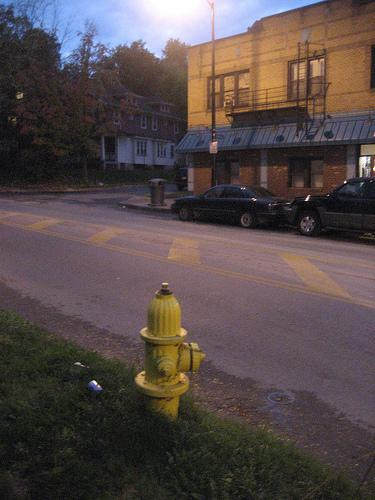Can you identify the type and colors of vehicles in the image and their parking positions? There are two black vehicles, a car and a truck, parked on the street with the car in front of the truck. Mention any unusual marking present on the road surface, and state its color. Blue paint markings are present on the road surface, which may indicate construction or maintenance work. In one sentence, describe the primary subject of the image and its color. The primary subject of the image is a yellow fire hydrant, placed on the street to assist firefighters. What object can be found in the grass, and what is its purpose? A drink can is found in the grass, which is a container for beverages but is considered litter in this context. State the location of the garbage can and provide a brief description. The garbage can is located on the sidewalk near the grass, providing a designated spot for people to dispose of their trash. In the image available, what can be seen painted on the road and what color are they? Yellow lines are painted on the road, likely serving as lane dividers or markings for parking restrictions. Describe the weather condition and the immediate surroundings in the image. The weather is clear with a blue sky, and the immediate surroundings include grass on the side of the road, trees with red buds, and a street lamp shining. Briefly describe the state of the road and the type of material it is made from. The road appears to be damp and is made from asphalt, a common material for road construction. What is the main object on the top left corner of the image and provide a short description about it. A yellow fire hydrant is present at the top left corner of the image, providing a water source for firefighters in case of emergencies. What type of building features can you identify in the image, and specify their locations? A balcony on a building, a fire escape ladder, and a two-story brick building are present in the image, providing architectural details and emergency access. 